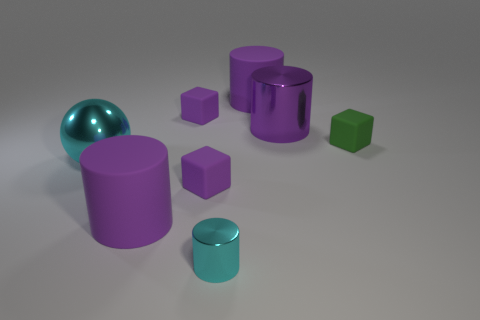Are there fewer cubes in front of the purple metal object than yellow matte balls?
Make the answer very short. No. There is a small cyan object that is made of the same material as the large sphere; what is its shape?
Your answer should be very brief. Cylinder. There is a large matte thing behind the large purple metal cylinder; is it the same shape as the large matte thing in front of the small green cube?
Keep it short and to the point. Yes. Are there fewer small objects that are in front of the tiny shiny object than small objects in front of the green rubber cube?
Ensure brevity in your answer.  Yes. What shape is the tiny object that is the same color as the large shiny ball?
Your answer should be compact. Cylinder. What number of purple matte cylinders are the same size as the cyan sphere?
Give a very brief answer. 2. Is the cyan thing that is right of the cyan ball made of the same material as the big ball?
Your response must be concise. Yes. Are there any shiny cylinders?
Give a very brief answer. Yes. There is a purple cylinder that is made of the same material as the cyan sphere; what is its size?
Offer a terse response. Large. Are there any tiny cylinders of the same color as the metallic sphere?
Give a very brief answer. Yes. 